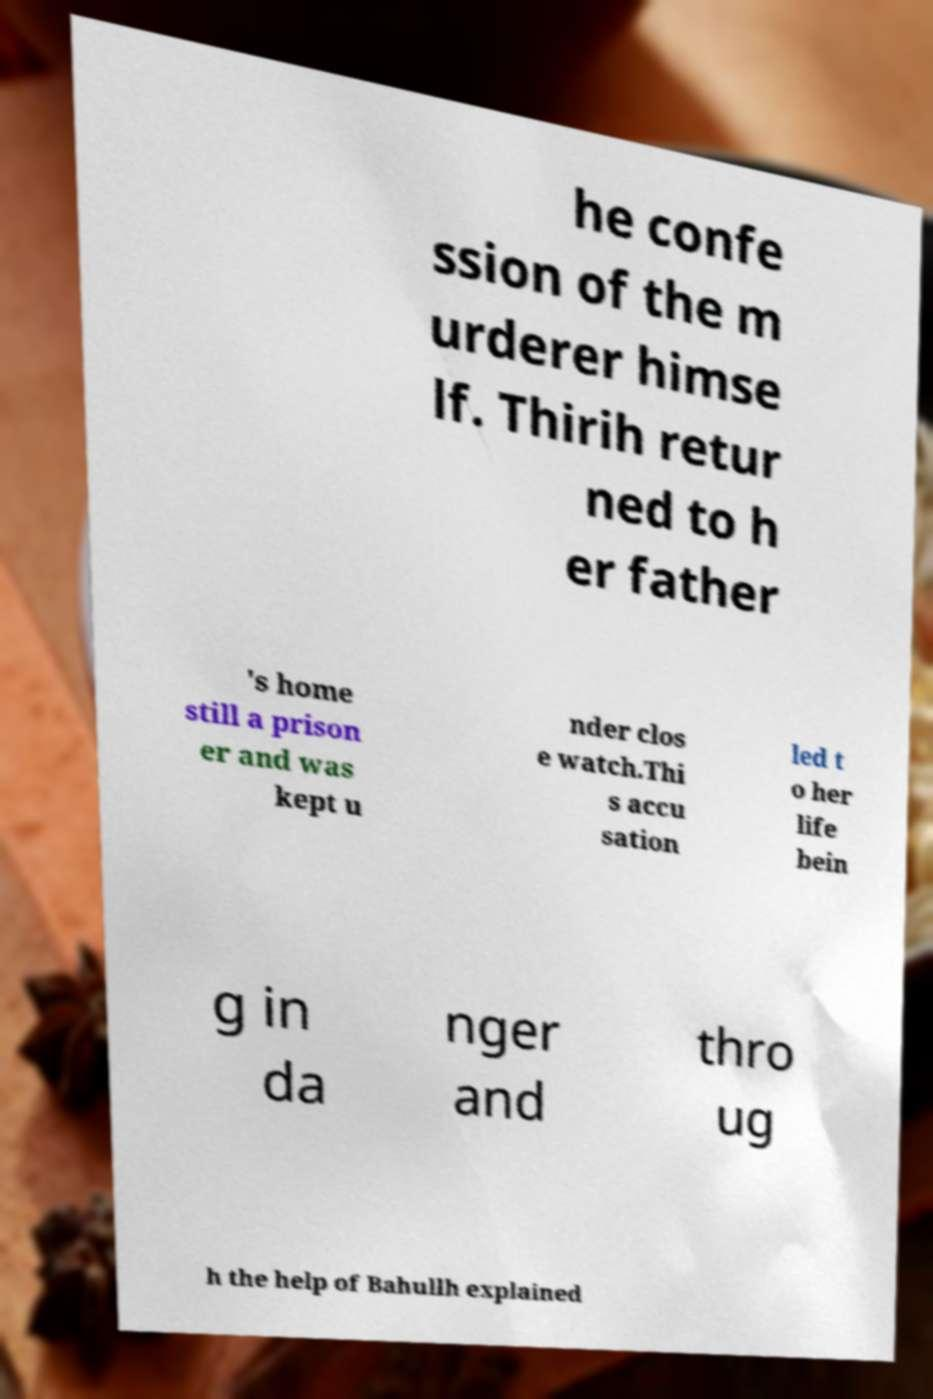For documentation purposes, I need the text within this image transcribed. Could you provide that? he confe ssion of the m urderer himse lf. Thirih retur ned to h er father 's home still a prison er and was kept u nder clos e watch.Thi s accu sation led t o her life bein g in da nger and thro ug h the help of Bahullh explained 